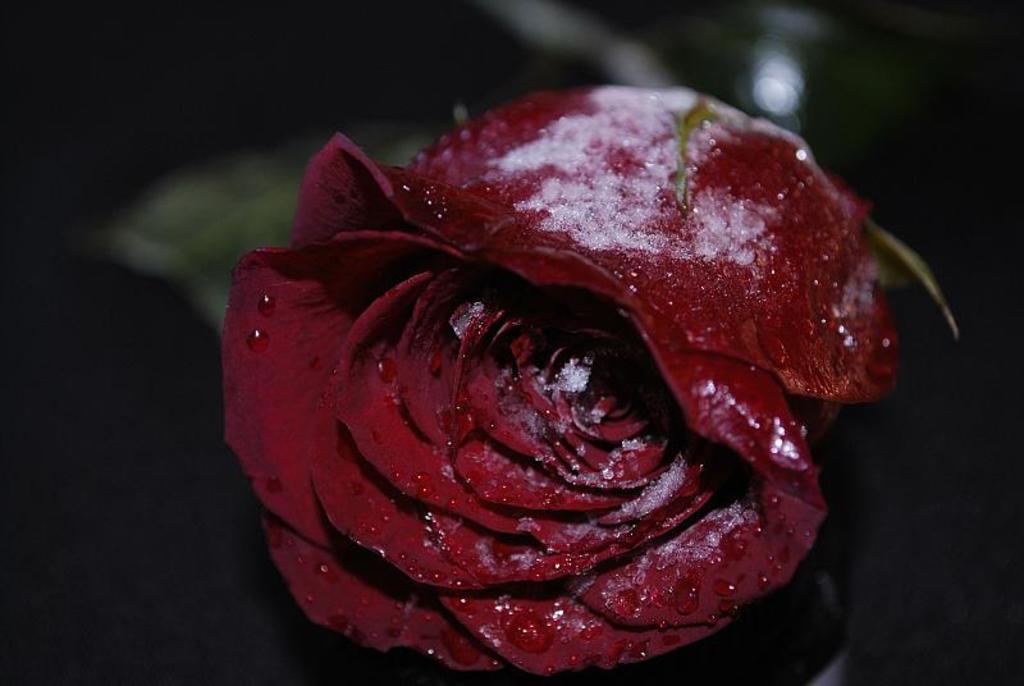How would you summarize this image in a sentence or two? There is a zoom in picture of a red color rose as we can see in the middle of this image. 